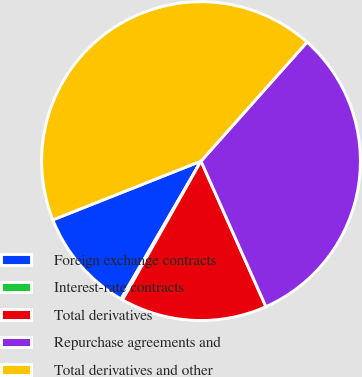Convert chart. <chart><loc_0><loc_0><loc_500><loc_500><pie_chart><fcel>Foreign exchange contracts<fcel>Interest-rate contracts<fcel>Total derivatives<fcel>Repurchase agreements and<fcel>Total derivatives and other<nl><fcel>10.63%<fcel>0.17%<fcel>14.87%<fcel>31.74%<fcel>42.59%<nl></chart> 